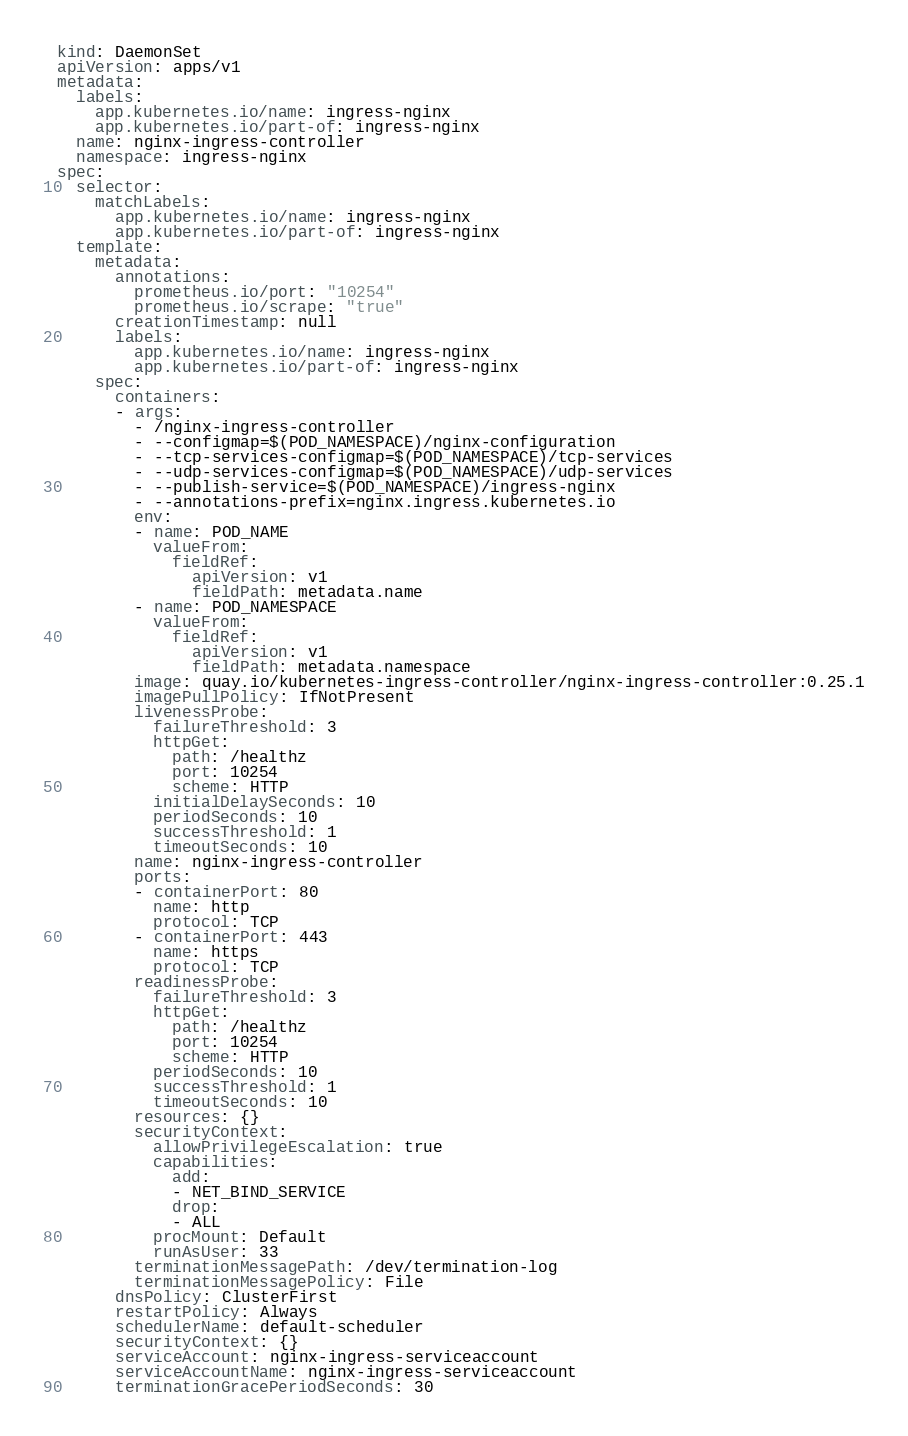Convert code to text. <code><loc_0><loc_0><loc_500><loc_500><_YAML_>kind: DaemonSet
apiVersion: apps/v1
metadata:
  labels:
    app.kubernetes.io/name: ingress-nginx
    app.kubernetes.io/part-of: ingress-nginx
  name: nginx-ingress-controller
  namespace: ingress-nginx
spec:
  selector:
    matchLabels:
      app.kubernetes.io/name: ingress-nginx
      app.kubernetes.io/part-of: ingress-nginx
  template:
    metadata:
      annotations:
        prometheus.io/port: "10254"
        prometheus.io/scrape: "true"
      creationTimestamp: null
      labels:
        app.kubernetes.io/name: ingress-nginx
        app.kubernetes.io/part-of: ingress-nginx
    spec:
      containers:
      - args:
        - /nginx-ingress-controller
        - --configmap=$(POD_NAMESPACE)/nginx-configuration
        - --tcp-services-configmap=$(POD_NAMESPACE)/tcp-services
        - --udp-services-configmap=$(POD_NAMESPACE)/udp-services
        - --publish-service=$(POD_NAMESPACE)/ingress-nginx
        - --annotations-prefix=nginx.ingress.kubernetes.io
        env:
        - name: POD_NAME
          valueFrom:
            fieldRef:
              apiVersion: v1
              fieldPath: metadata.name
        - name: POD_NAMESPACE
          valueFrom:
            fieldRef:
              apiVersion: v1
              fieldPath: metadata.namespace
        image: quay.io/kubernetes-ingress-controller/nginx-ingress-controller:0.25.1
        imagePullPolicy: IfNotPresent
        livenessProbe:
          failureThreshold: 3
          httpGet:
            path: /healthz
            port: 10254
            scheme: HTTP
          initialDelaySeconds: 10
          periodSeconds: 10
          successThreshold: 1
          timeoutSeconds: 10
        name: nginx-ingress-controller
        ports:
        - containerPort: 80
          name: http
          protocol: TCP
        - containerPort: 443
          name: https
          protocol: TCP
        readinessProbe:
          failureThreshold: 3
          httpGet:
            path: /healthz
            port: 10254
            scheme: HTTP
          periodSeconds: 10
          successThreshold: 1
          timeoutSeconds: 10
        resources: {}
        securityContext:
          allowPrivilegeEscalation: true
          capabilities:
            add:
            - NET_BIND_SERVICE
            drop:
            - ALL
          procMount: Default
          runAsUser: 33
        terminationMessagePath: /dev/termination-log
        terminationMessagePolicy: File
      dnsPolicy: ClusterFirst
      restartPolicy: Always
      schedulerName: default-scheduler
      securityContext: {}
      serviceAccount: nginx-ingress-serviceaccount
      serviceAccountName: nginx-ingress-serviceaccount
      terminationGracePeriodSeconds: 30</code> 